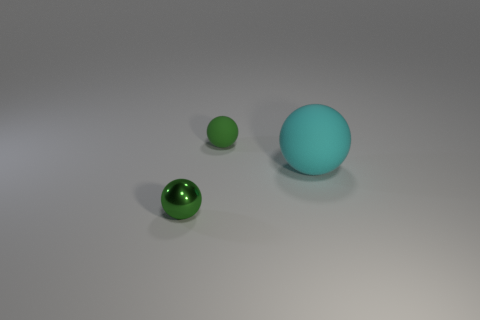Add 2 small blue rubber cylinders. How many objects exist? 5 Subtract all tiny spheres. Subtract all green matte spheres. How many objects are left? 0 Add 3 green objects. How many green objects are left? 5 Add 1 large things. How many large things exist? 2 Subtract 0 gray blocks. How many objects are left? 3 